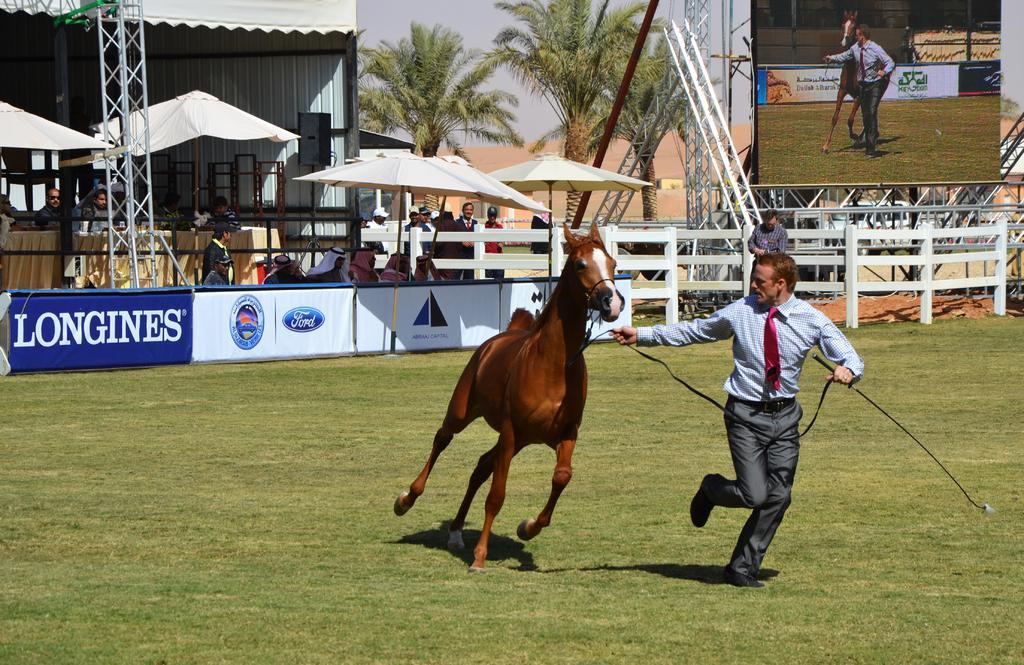Describe this image in one or two sentences. In this picture i could see a person holding the horse tail and running along with the horse, it looks like court with green grass. In the background i could see some persons standing and watching the show under the umbrellas back of him there are some trees and a wall screen. 